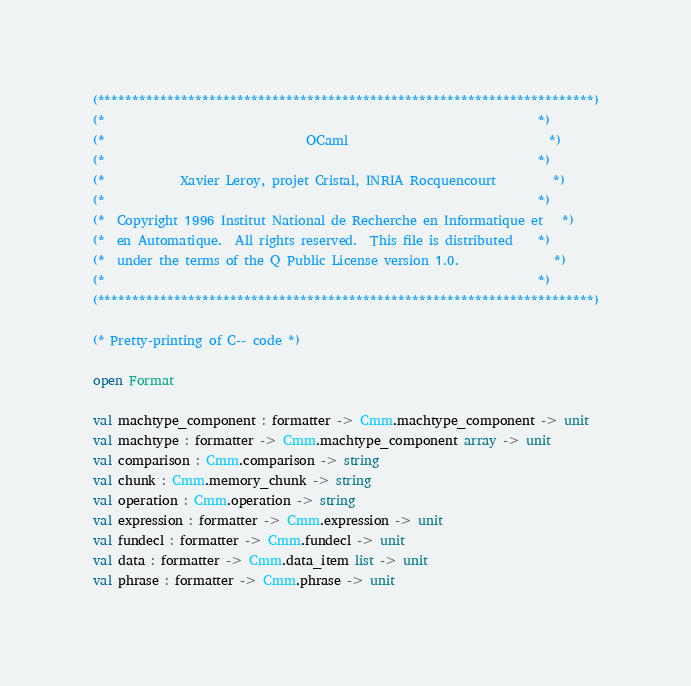Convert code to text. <code><loc_0><loc_0><loc_500><loc_500><_OCaml_>(***********************************************************************)
(*                                                                     *)
(*                                OCaml                                *)
(*                                                                     *)
(*            Xavier Leroy, projet Cristal, INRIA Rocquencourt         *)
(*                                                                     *)
(*  Copyright 1996 Institut National de Recherche en Informatique et   *)
(*  en Automatique.  All rights reserved.  This file is distributed    *)
(*  under the terms of the Q Public License version 1.0.               *)
(*                                                                     *)
(***********************************************************************)

(* Pretty-printing of C-- code *)

open Format

val machtype_component : formatter -> Cmm.machtype_component -> unit
val machtype : formatter -> Cmm.machtype_component array -> unit
val comparison : Cmm.comparison -> string
val chunk : Cmm.memory_chunk -> string
val operation : Cmm.operation -> string
val expression : formatter -> Cmm.expression -> unit
val fundecl : formatter -> Cmm.fundecl -> unit
val data : formatter -> Cmm.data_item list -> unit
val phrase : formatter -> Cmm.phrase -> unit
</code> 